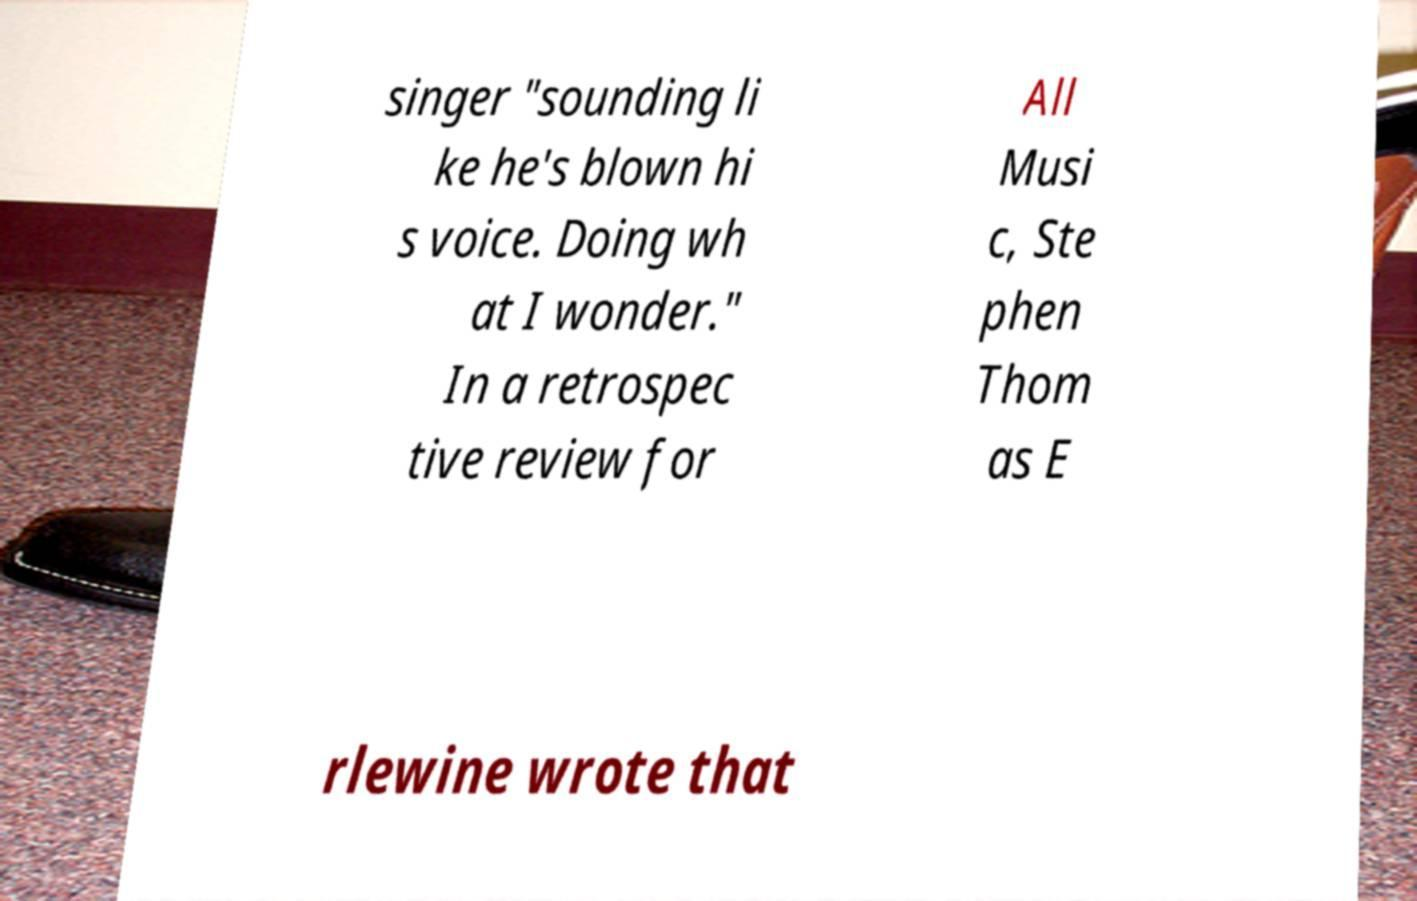Can you accurately transcribe the text from the provided image for me? singer "sounding li ke he's blown hi s voice. Doing wh at I wonder." In a retrospec tive review for All Musi c, Ste phen Thom as E rlewine wrote that 